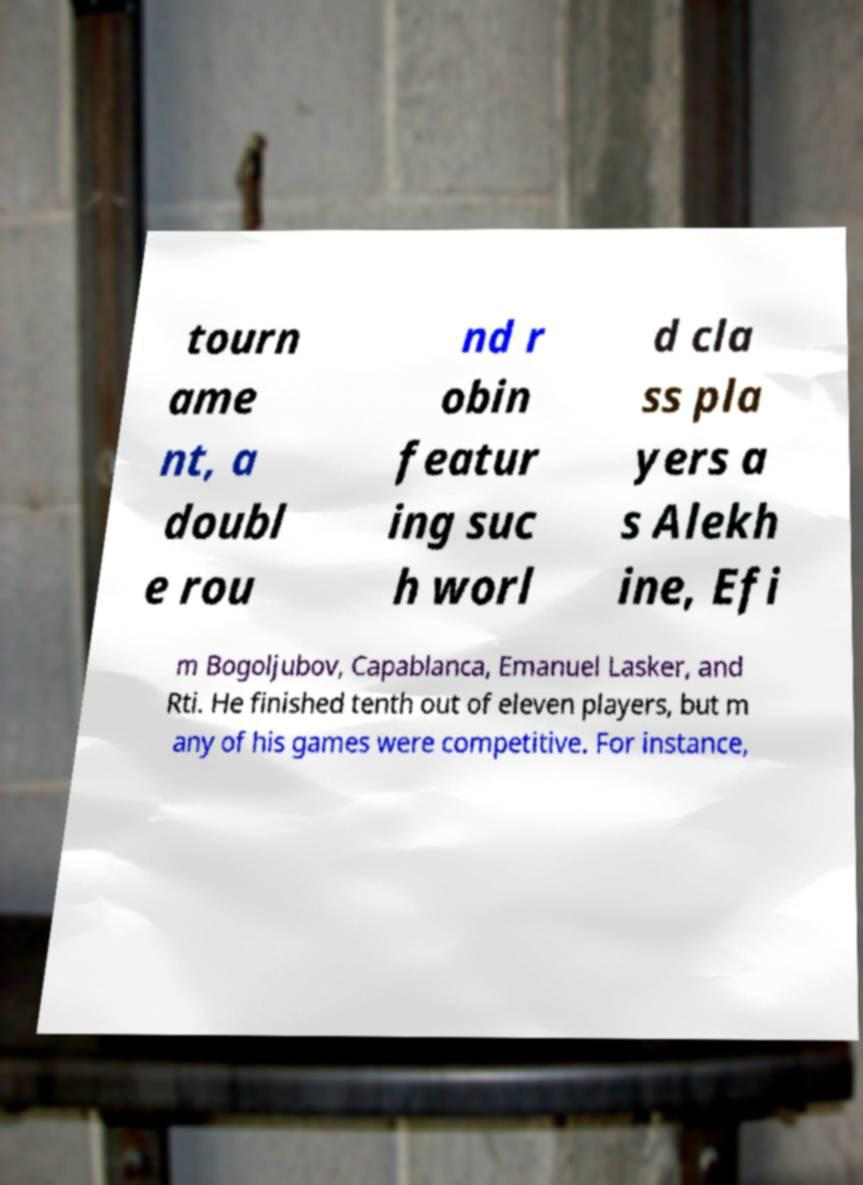Could you assist in decoding the text presented in this image and type it out clearly? tourn ame nt, a doubl e rou nd r obin featur ing suc h worl d cla ss pla yers a s Alekh ine, Efi m Bogoljubov, Capablanca, Emanuel Lasker, and Rti. He finished tenth out of eleven players, but m any of his games were competitive. For instance, 